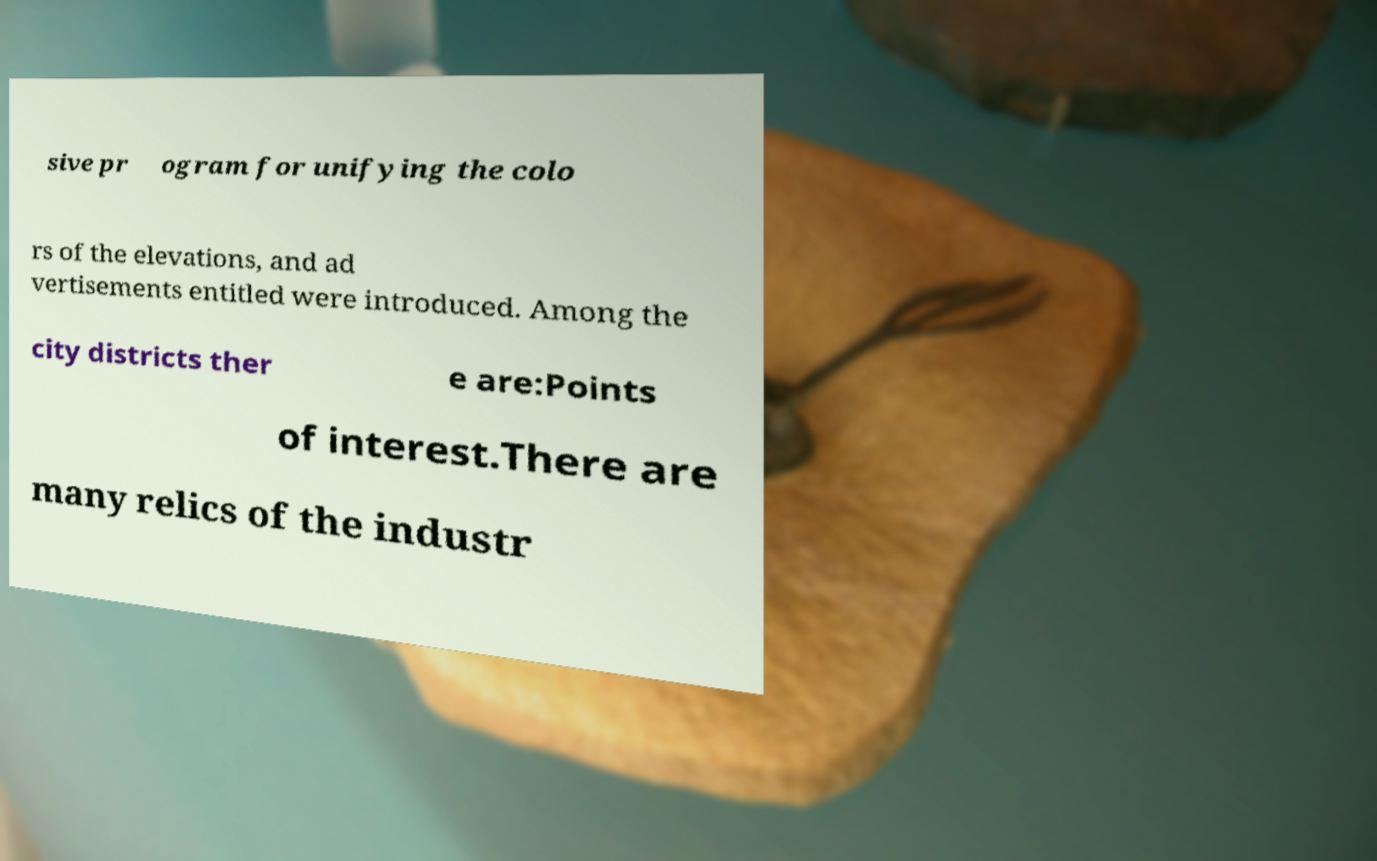Can you accurately transcribe the text from the provided image for me? sive pr ogram for unifying the colo rs of the elevations, and ad vertisements entitled were introduced. Among the city districts ther e are:Points of interest.There are many relics of the industr 